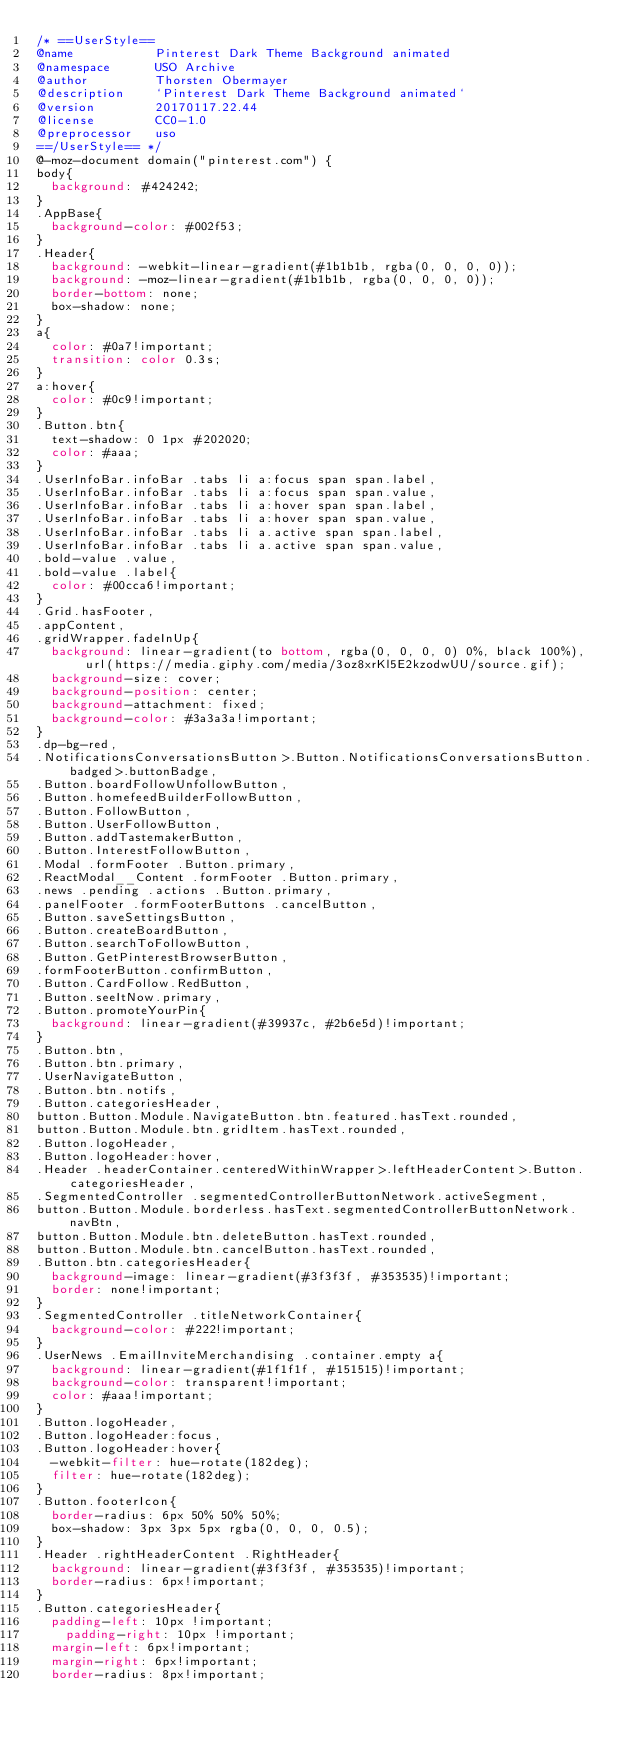Convert code to text. <code><loc_0><loc_0><loc_500><loc_500><_CSS_>/* ==UserStyle==
@name           Pinterest Dark Theme Background animated
@namespace      USO Archive
@author         Thorsten Obermayer
@description    `Pinterest Dark Theme Background animated`
@version        20170117.22.44
@license        CC0-1.0
@preprocessor   uso
==/UserStyle== */
@-moz-document domain("pinterest.com") {
body{
	background: #424242;
}
.AppBase{
	background-color: #002f53;
}
.Header{
	background: -webkit-linear-gradient(#1b1b1b, rgba(0, 0, 0, 0));
	background: -moz-linear-gradient(#1b1b1b, rgba(0, 0, 0, 0));
	border-bottom: none;
	box-shadow: none;
}
a{
	color: #0a7!important;
	transition: color 0.3s;
}
a:hover{
	color: #0c9!important;
}
.Button.btn{
	text-shadow: 0 1px #202020;
	color: #aaa;
}
.UserInfoBar.infoBar .tabs li a:focus span span.label,
.UserInfoBar.infoBar .tabs li a:focus span span.value,
.UserInfoBar.infoBar .tabs li a:hover span span.label,
.UserInfoBar.infoBar .tabs li a:hover span span.value,
.UserInfoBar.infoBar .tabs li a.active span span.label,
.UserInfoBar.infoBar .tabs li a.active span span.value,
.bold-value .value,
.bold-value .label{
	color: #00cca6!important;
}
.Grid.hasFooter,
.appContent,
.gridWrapper.fadeInUp{
	background: linear-gradient(to bottom, rgba(0, 0, 0, 0) 0%, black 100%), url(https://media.giphy.com/media/3oz8xrKl5E2kzodwUU/source.gif);
	background-size: cover;
	background-position: center;
	background-attachment: fixed;
	background-color: #3a3a3a!important;
}
.dp-bg-red,
.NotificationsConversationsButton>.Button.NotificationsConversationsButton.badged>.buttonBadge,
.Button.boardFollowUnfollowButton,
.Button.homefeedBuilderFollowButton,
.Button.FollowButton,
.Button.UserFollowButton,
.Button.addTastemakerButton,
.Button.InterestFollowButton,
.Modal .formFooter .Button.primary,
.ReactModal__Content .formFooter .Button.primary,
.news .pending .actions .Button.primary,
.panelFooter .formFooterButtons .cancelButton,
.Button.saveSettingsButton,
.Button.createBoardButton,
.Button.searchToFollowButton,
.Button.GetPinterestBrowserButton,
.formFooterButton.confirmButton,
.Button.CardFollow.RedButton,
.Button.seeItNow.primary,
.Button.promoteYourPin{
	background: linear-gradient(#39937c, #2b6e5d)!important;
}
.Button.btn,
.Button.btn.primary,
.UserNavigateButton,
.Button.btn.notifs, 
.Button.categoriesHeader,
button.Button.Module.NavigateButton.btn.featured.hasText.rounded,
button.Button.Module.btn.gridItem.hasText.rounded,
.Button.logoHeader,
.Button.logoHeader:hover,
.Header .headerContainer.centeredWithinWrapper>.leftHeaderContent>.Button.categoriesHeader,
.SegmentedController .segmentedControllerButtonNetwork.activeSegment,
button.Button.Module.borderless.hasText.segmentedControllerButtonNetwork.navBtn,
button.Button.Module.btn.deleteButton.hasText.rounded,
button.Button.Module.btn.cancelButton.hasText.rounded,
.Button.btn.categoriesHeader{
	background-image: linear-gradient(#3f3f3f, #353535)!important;
	border: none!important;
}
.SegmentedController .titleNetworkContainer{
	background-color: #222!important;
}
.UserNews .EmailInviteMerchandising .container.empty a{
	background: linear-gradient(#1f1f1f, #151515)!important;
	background-color: transparent!important;
	color: #aaa!important;
}
.Button.logoHeader,
.Button.logoHeader:focus,
.Button.logoHeader:hover{
	-webkit-filter: hue-rotate(182deg);
	filter: hue-rotate(182deg);
}
.Button.footerIcon{
	border-radius: 6px 50% 50% 50%;
	box-shadow: 3px 3px 5px rgba(0, 0, 0, 0.5);
}
.Header .rightHeaderContent .RightHeader{
	background: linear-gradient(#3f3f3f, #353535)!important;
	border-radius: 6px!important;
}
.Button.categoriesHeader{
	padding-left: 10px !important;
    padding-right: 10px !important;
	margin-left: 6px!important;
	margin-right: 6px!important;
	border-radius: 8px!important;</code> 